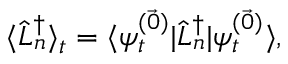<formula> <loc_0><loc_0><loc_500><loc_500>\langle \hat { L } _ { n } ^ { \dagger } \rangle _ { t } = \langle \psi _ { t } ^ { ( \vec { 0 } ) } | \hat { L } _ { n } ^ { \dagger } | \psi _ { t } ^ { ( \vec { 0 } ) } \rangle ,</formula> 